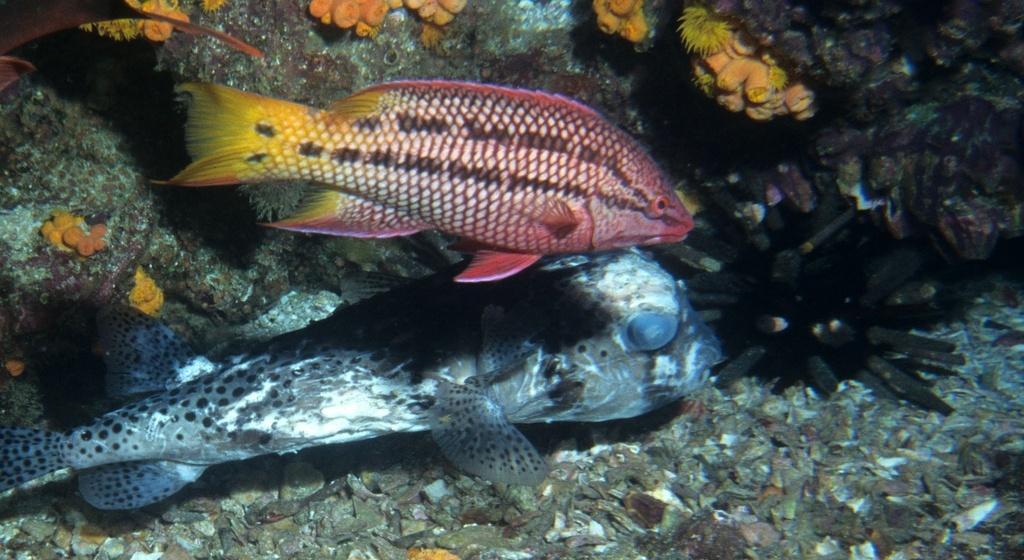Describe this image in one or two sentences. There are two fishes in the water. Also there are corals. 